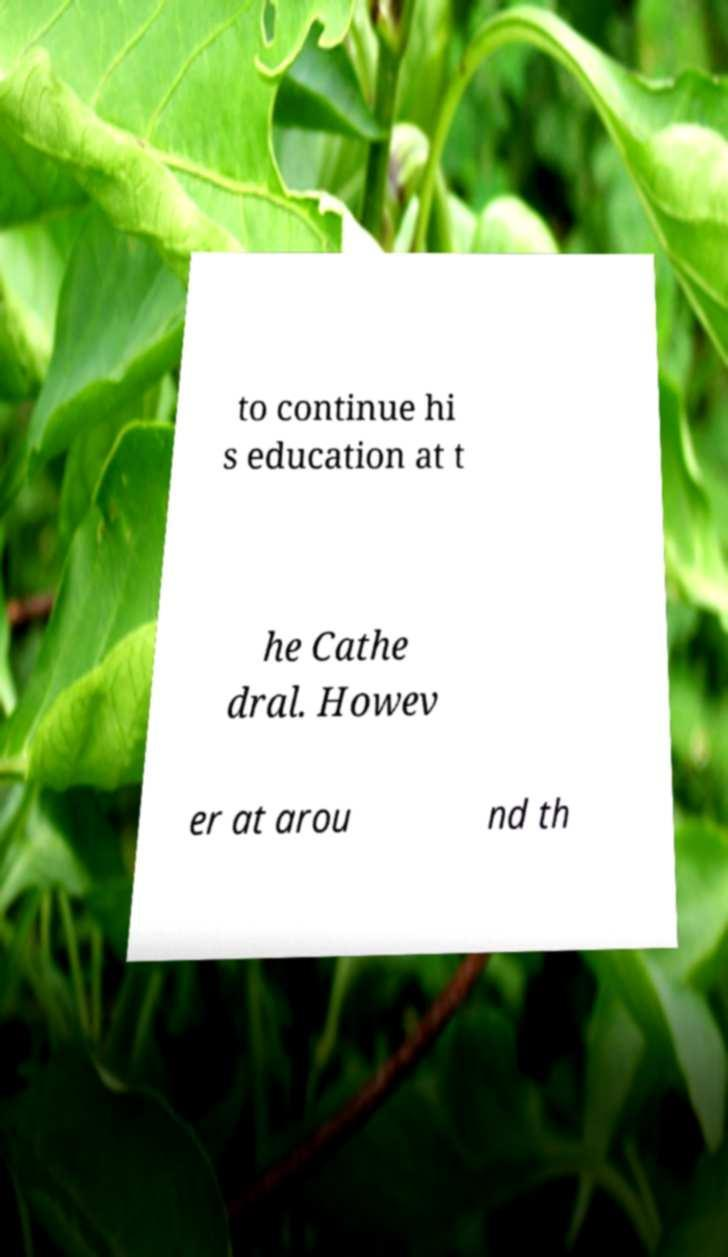Can you read and provide the text displayed in the image?This photo seems to have some interesting text. Can you extract and type it out for me? to continue hi s education at t he Cathe dral. Howev er at arou nd th 